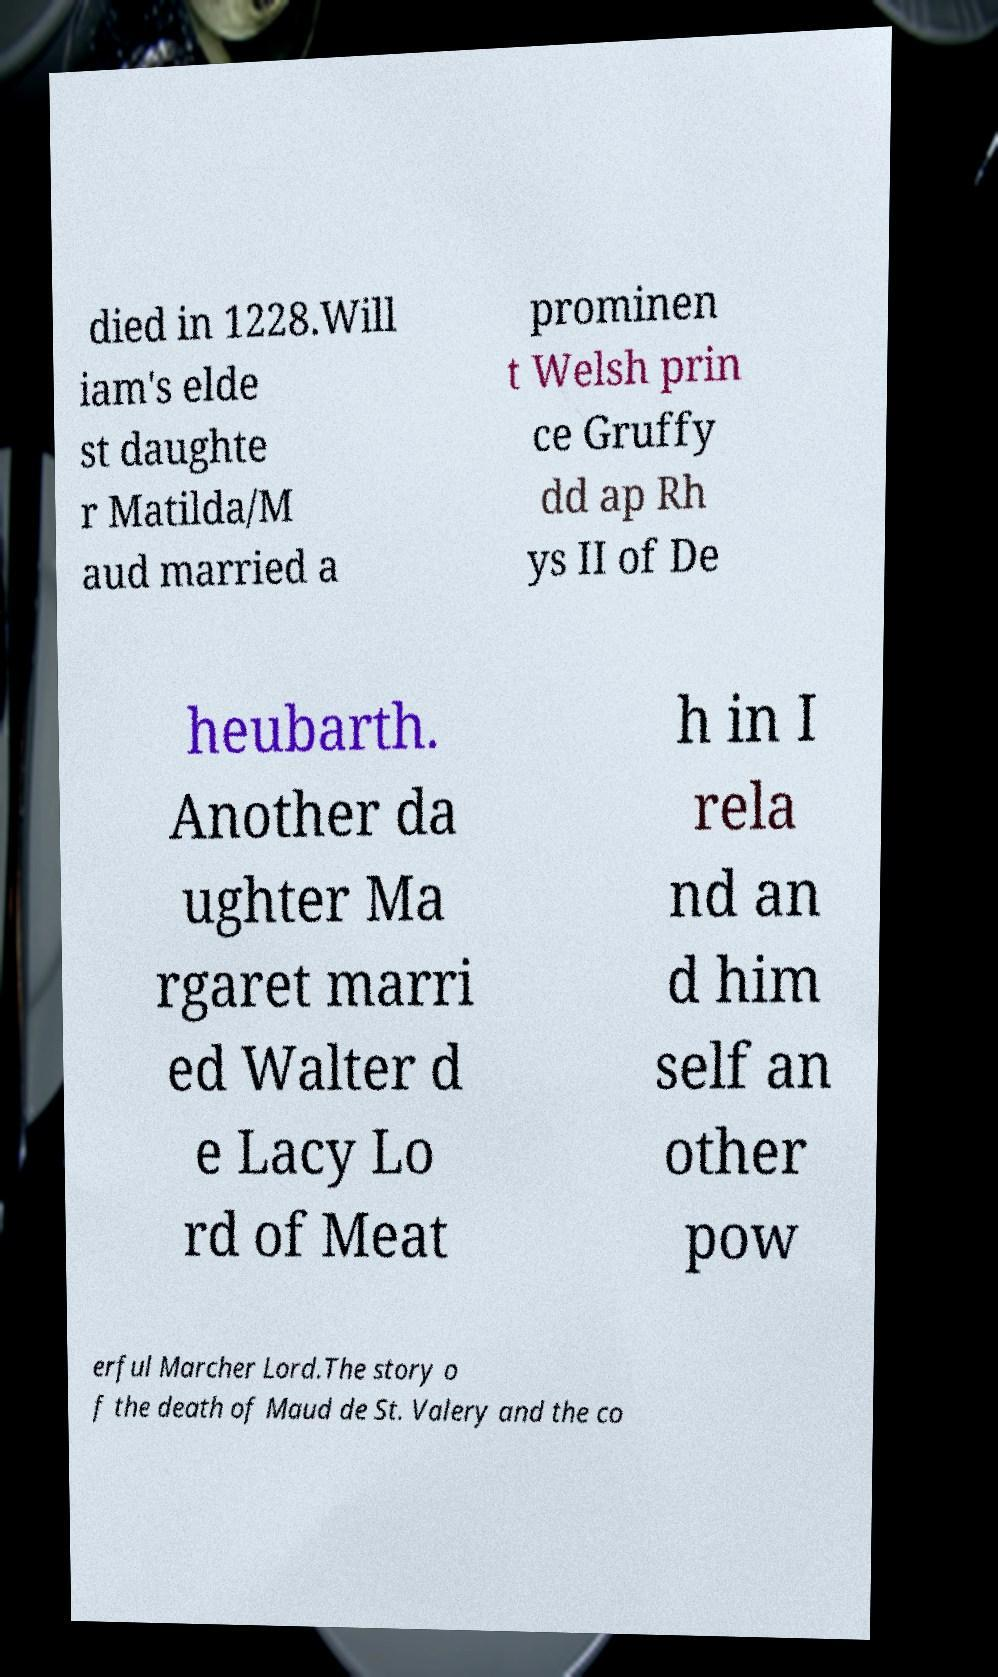Could you assist in decoding the text presented in this image and type it out clearly? died in 1228.Will iam's elde st daughte r Matilda/M aud married a prominen t Welsh prin ce Gruffy dd ap Rh ys II of De heubarth. Another da ughter Ma rgaret marri ed Walter d e Lacy Lo rd of Meat h in I rela nd an d him self an other pow erful Marcher Lord.The story o f the death of Maud de St. Valery and the co 